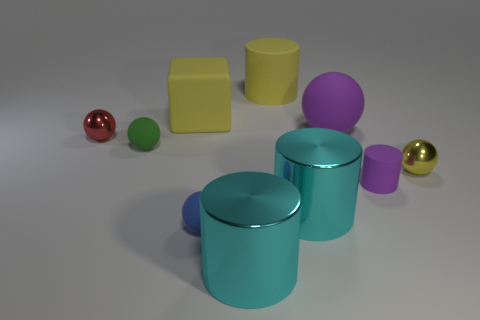How many other things are there of the same size as the purple matte ball?
Provide a short and direct response. 4. Are there fewer blue rubber balls than large things?
Ensure brevity in your answer.  Yes. The tiny yellow thing is what shape?
Your response must be concise. Sphere. Does the small metallic thing right of the red shiny ball have the same color as the big block?
Your response must be concise. Yes. The rubber thing that is both behind the small green rubber object and right of the large yellow cylinder has what shape?
Your answer should be very brief. Sphere. What is the color of the metal sphere right of the small red thing?
Your response must be concise. Yellow. Is there any other thing of the same color as the large rubber cylinder?
Provide a succinct answer. Yes. Do the purple cylinder and the block have the same size?
Your answer should be compact. No. There is a yellow object that is right of the large cube and behind the red ball; what is its size?
Offer a very short reply. Large. How many cylinders have the same material as the small purple thing?
Provide a succinct answer. 1. 